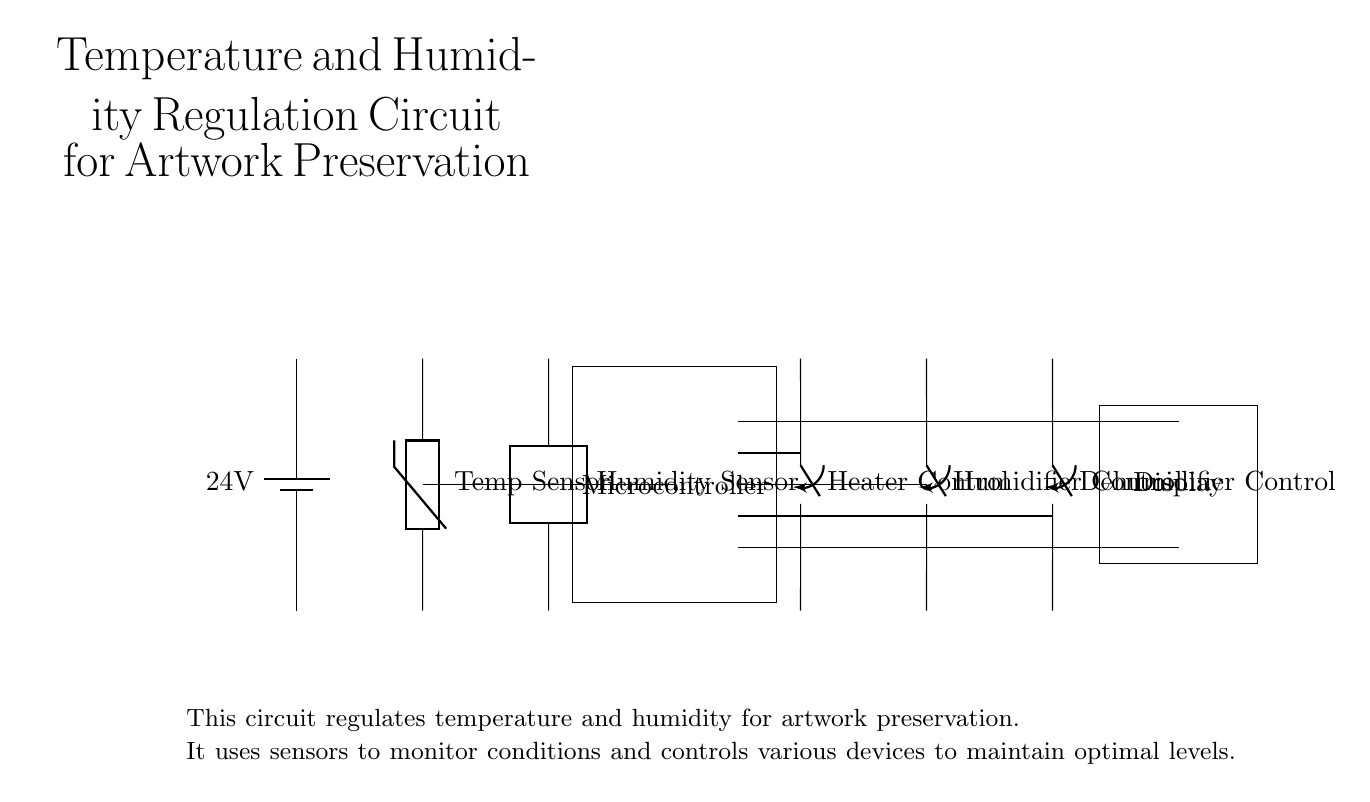What is the voltage supply in this circuit? The circuit uses a battery labeled with 24 volts, providing the necessary power for operation.
Answer: 24 volts What components are used to measure environmental conditions? The circuit includes a thermistor for temperature measurement and a two-port device for humidity measurement, which together help monitor the environment.
Answer: Thermistor and Humidity Sensor How many control devices are there for climate regulation? There are three control devices in the circuit: a heater, a humidifier, and a dehumidifier, which work together to maintain optimal conditions for artwork preservation.
Answer: Three What role does the microcontroller play in this circuit? The microcontroller acts as the central processing unit, receiving data from the sensors and sending signals to control the heater, humidifier, and dehumidifier accordingly.
Answer: Central processing unit Which component provides information to the user? The display shows the current temperature and humidity readings, allowing users to monitor the environmental conditions in real-time.
Answer: Display How does the circuit maintain temperature and humidity? The circuit utilizes feedback from the temperature and humidity sensors to control the heater, humidifier, and dehumidifier automatically, adjusting the environment as needed.
Answer: Feedback control What is indicated by the term "closing switch" in this context? The term "closing switch" signifies that these are electronic switches that connect or disconnect power to the respective heating and humidity control devices based on the microcontroller's instructions.
Answer: Electronic switches 